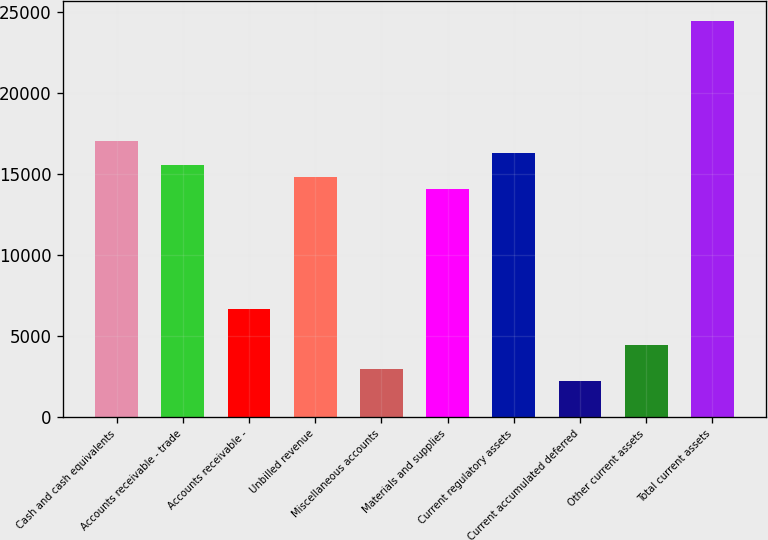Convert chart to OTSL. <chart><loc_0><loc_0><loc_500><loc_500><bar_chart><fcel>Cash and cash equivalents<fcel>Accounts receivable - trade<fcel>Accounts receivable -<fcel>Unbilled revenue<fcel>Miscellaneous accounts<fcel>Materials and supplies<fcel>Current regulatory assets<fcel>Current accumulated deferred<fcel>Other current assets<fcel>Total current assets<nl><fcel>17023.4<fcel>15543.8<fcel>6666.2<fcel>14804<fcel>2967.2<fcel>14064.2<fcel>16283.6<fcel>2227.4<fcel>4446.8<fcel>24421.4<nl></chart> 